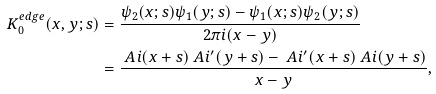Convert formula to latex. <formula><loc_0><loc_0><loc_500><loc_500>K _ { 0 } ^ { e d g e } ( x , y ; s ) & = \frac { \psi _ { 2 } ( x ; s ) \psi _ { 1 } ( y ; s ) - \psi _ { 1 } ( x ; s ) \psi _ { 2 } ( y ; s ) } { 2 \pi i ( x - y ) } \\ & = \frac { \ A i ( x + s ) \ A i ^ { \prime } ( y + s ) - \ A i ^ { \prime } ( x + s ) \ A i ( y + s ) } { x - y } ,</formula> 